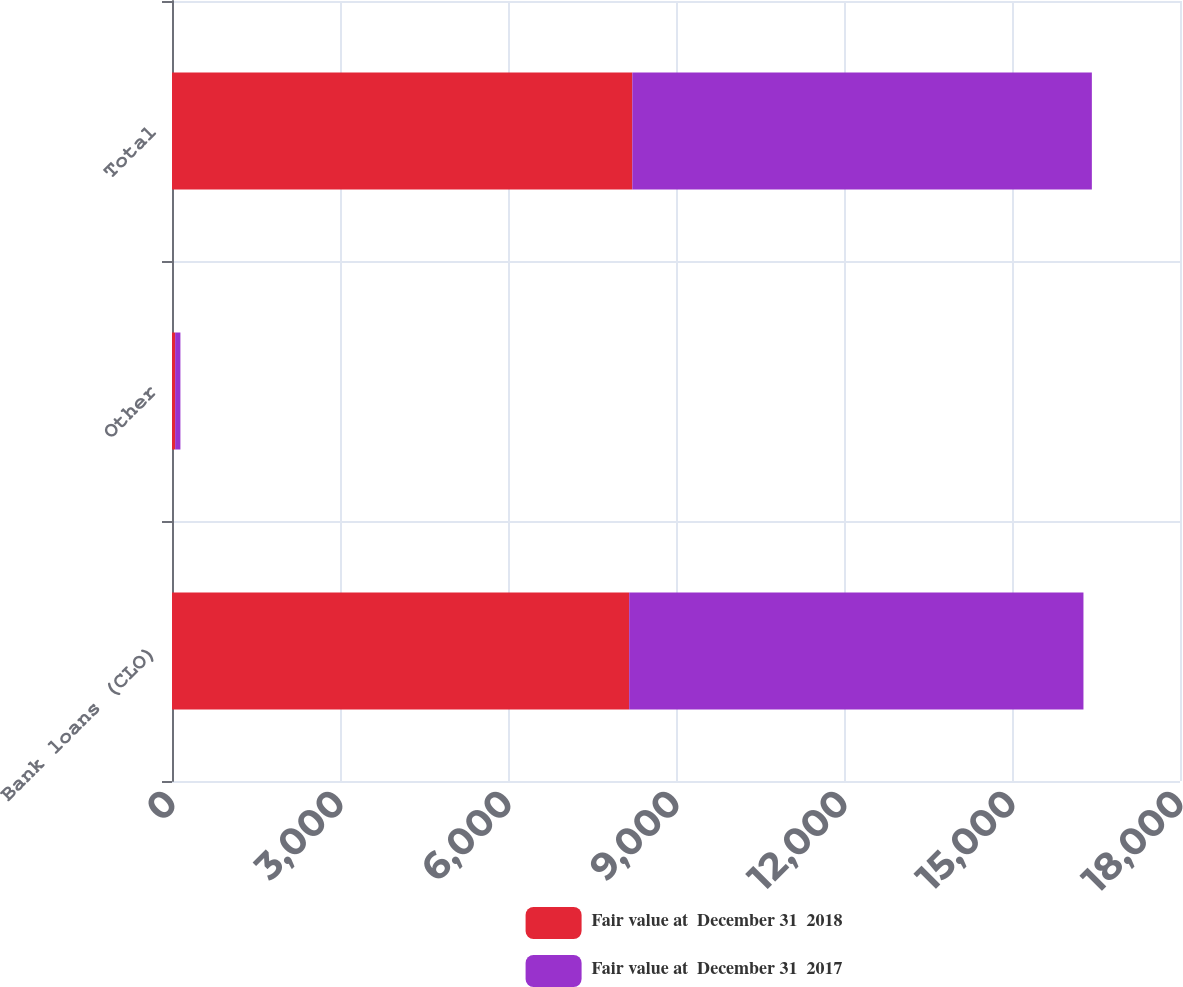Convert chart. <chart><loc_0><loc_0><loc_500><loc_500><stacked_bar_chart><ecel><fcel>Bank loans (CLO)<fcel>Other<fcel>Total<nl><fcel>Fair value at  December 31  2018<fcel>8164<fcel>56<fcel>8220<nl><fcel>Fair value at  December 31  2017<fcel>8112<fcel>94<fcel>8206<nl></chart> 